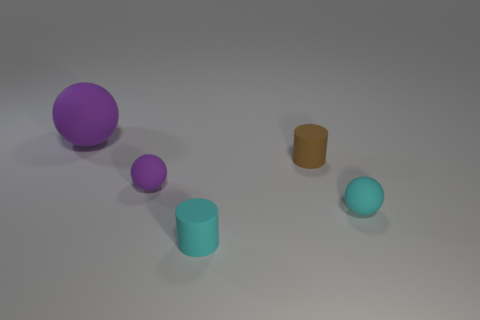What number of tiny cyan objects are there? 2 